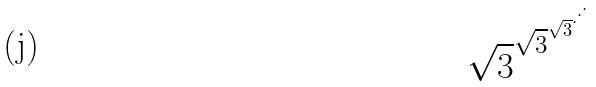<formula> <loc_0><loc_0><loc_500><loc_500>\sqrt { 3 } ^ { \sqrt { 3 } ^ { \sqrt { 3 } ^ { \cdot ^ { \cdot ^ { \cdot } } } } }</formula> 